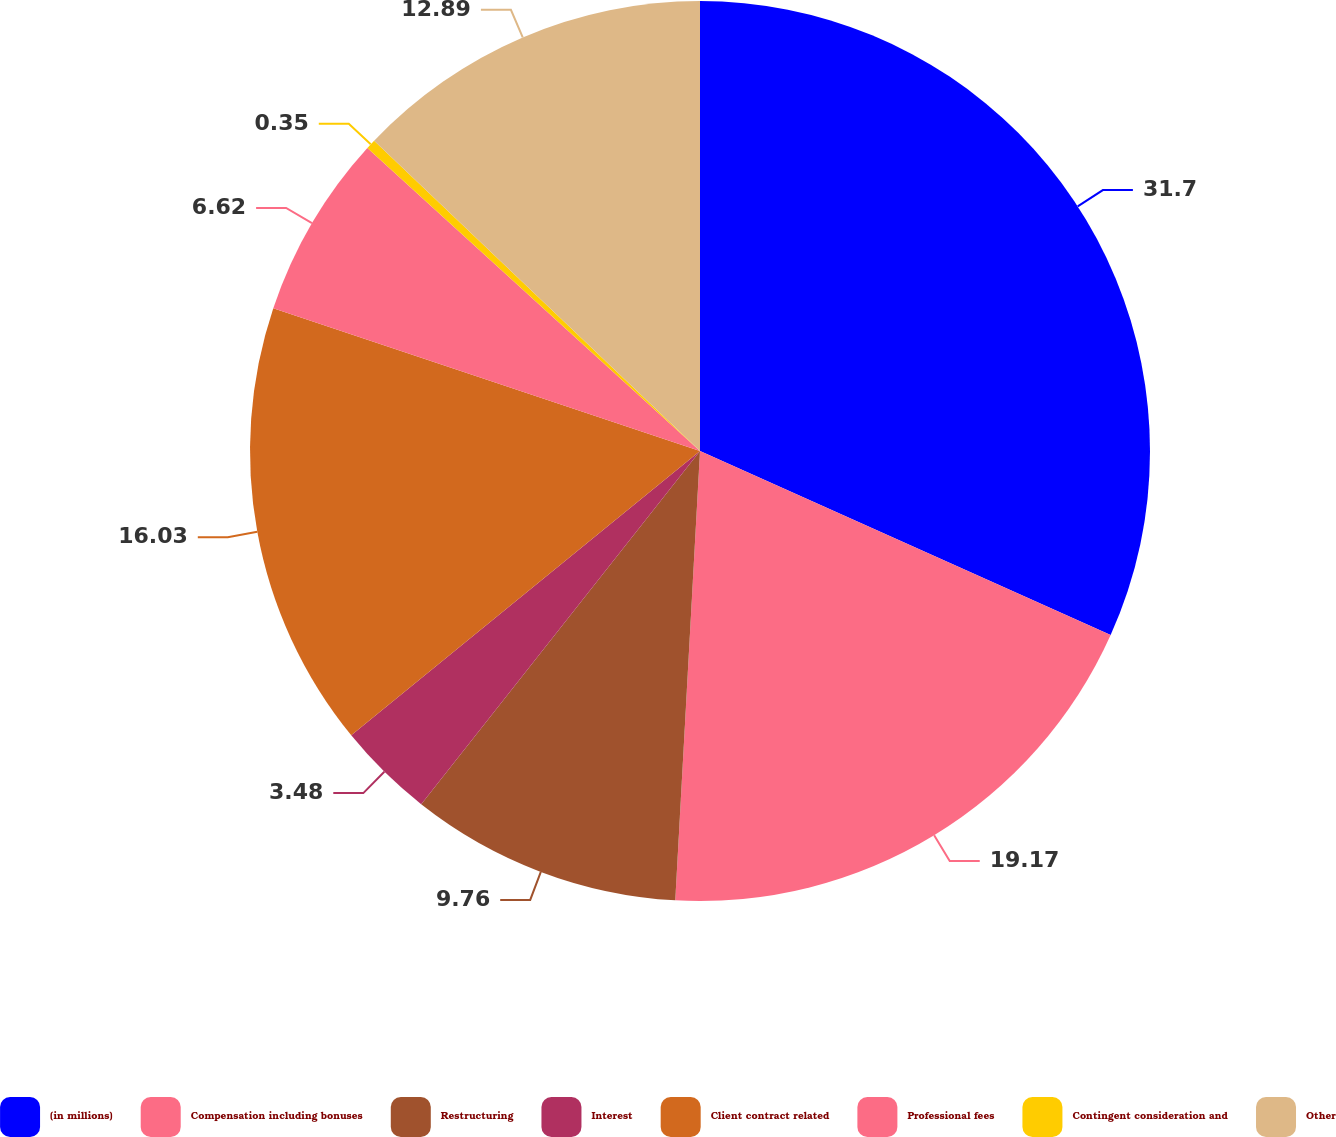Convert chart to OTSL. <chart><loc_0><loc_0><loc_500><loc_500><pie_chart><fcel>(in millions)<fcel>Compensation including bonuses<fcel>Restructuring<fcel>Interest<fcel>Client contract related<fcel>Professional fees<fcel>Contingent consideration and<fcel>Other<nl><fcel>31.71%<fcel>19.17%<fcel>9.76%<fcel>3.48%<fcel>16.03%<fcel>6.62%<fcel>0.35%<fcel>12.89%<nl></chart> 